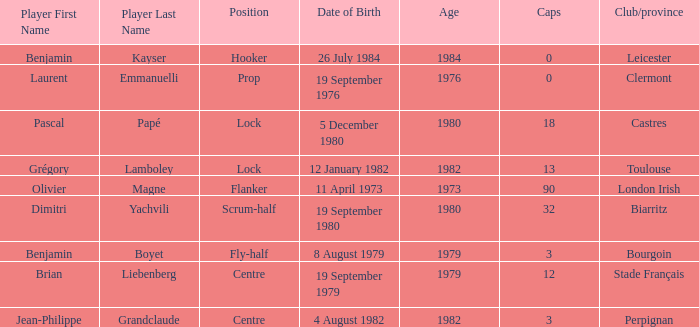Where is perpignan situated? Centre. 